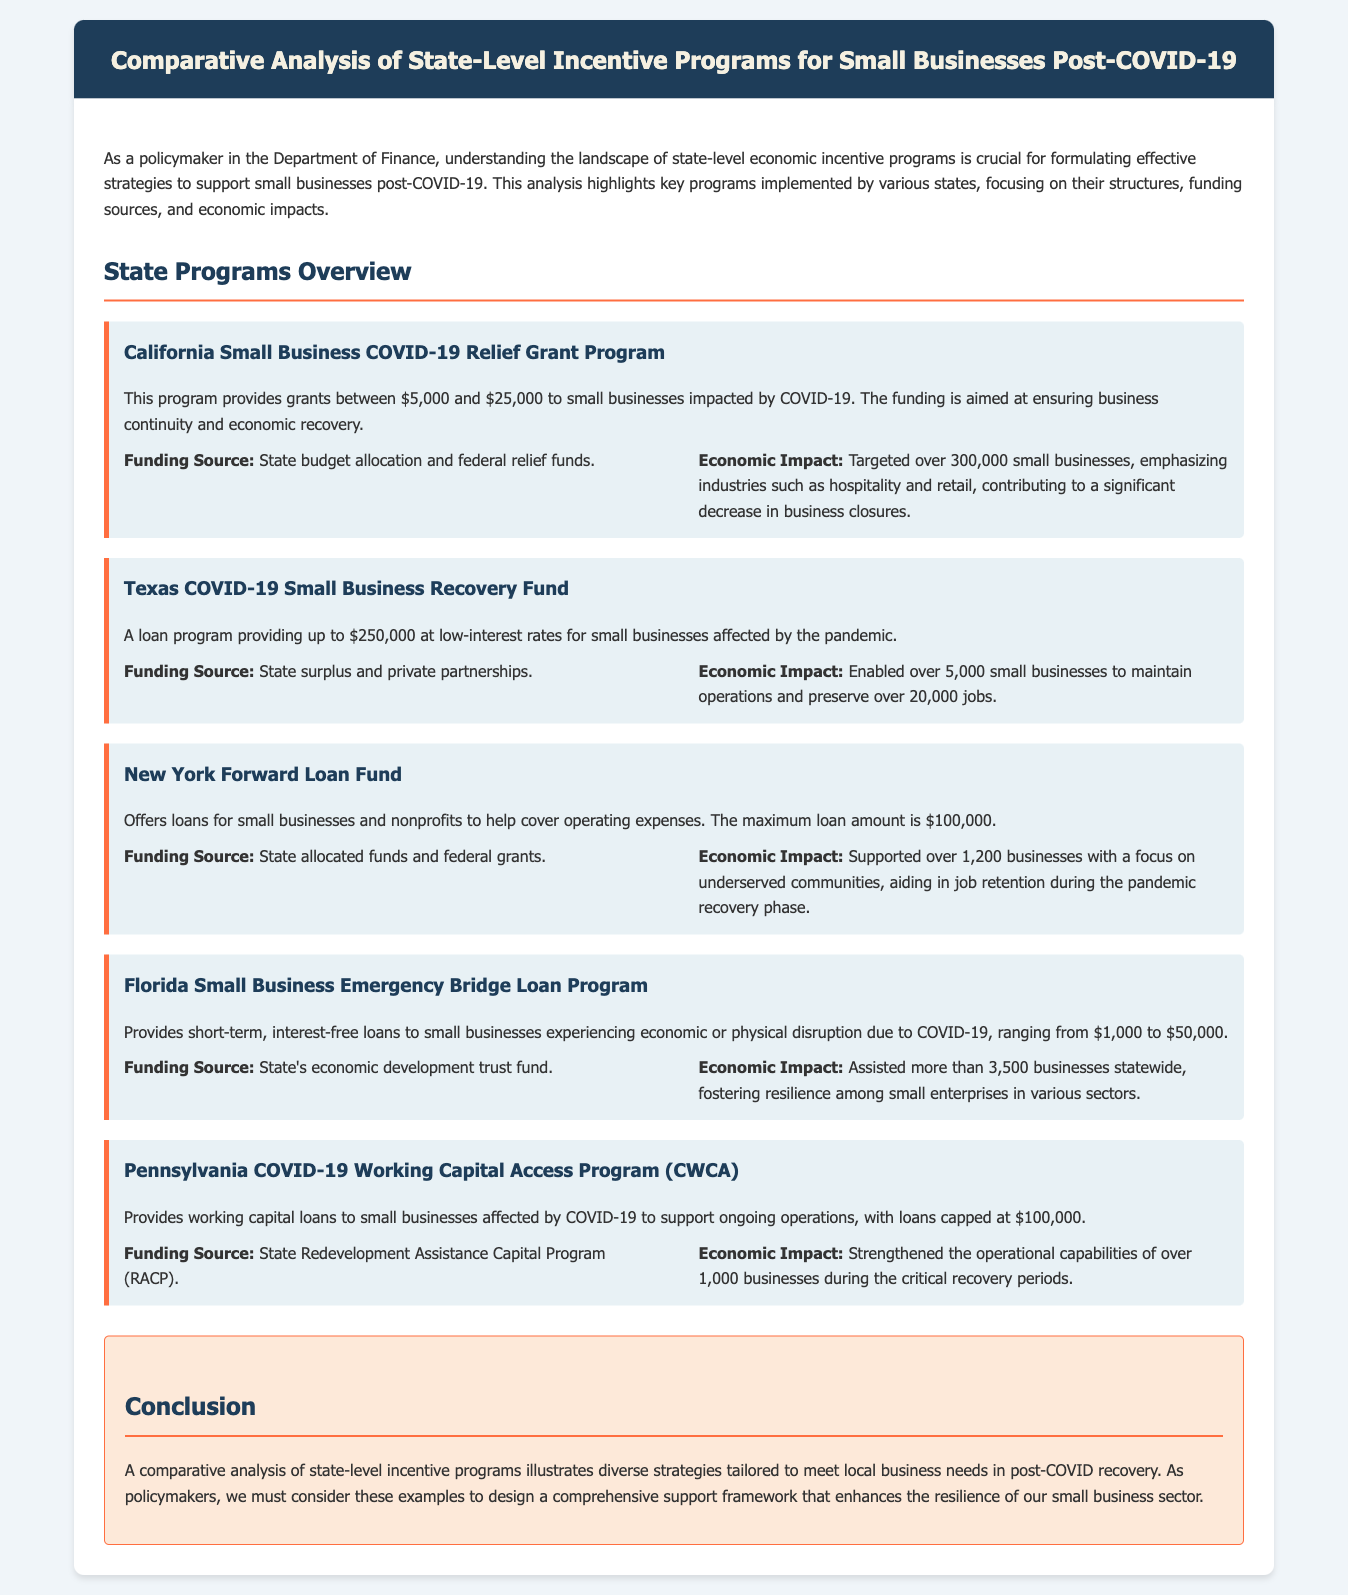what is the maximum grant amount in California’s program? California's program offers grants between $5,000 and $25,000, so the maximum grant amount is $25,000.
Answer: $25,000 what is the primary funding source for the Texas Recovery Fund? The Texas COVID-19 Small Business Recovery Fund is funded by the state surplus and private partnerships.
Answer: State surplus and private partnerships how many businesses did the New York Forward Loan Fund support? The New York Forward Loan Fund supported over 1,200 businesses.
Answer: Over 1,200 businesses what is the maximum loan amount for the Florida Emergency Bridge Loan Program? The Florida Small Business Emergency Bridge Loan Program provides loans ranging from $1,000 to $50,000, so the maximum amount is $50,000.
Answer: $50,000 what economic impact did the California program have on business closures? The California program contributed to a significant decrease in business closures by targeting over 300,000 small businesses.
Answer: Significant decrease in business closures which state program assists small businesses with working capital loans? The Pennsylvania COVID-19 Working Capital Access Program provides working capital loans to small businesses affected by COVID-19.
Answer: Pennsylvania COVID-19 Working Capital Access Program which program emphasizes aiding underserved communities? The New York Forward Loan Fund focuses on aiding underserved communities in its support to businesses.
Answer: New York Forward Loan Fund what was the total number of jobs preserved by Texas’s program? The Texas COVID-19 Small Business Recovery Fund helped preserve over 20,000 jobs.
Answer: Over 20,000 jobs 